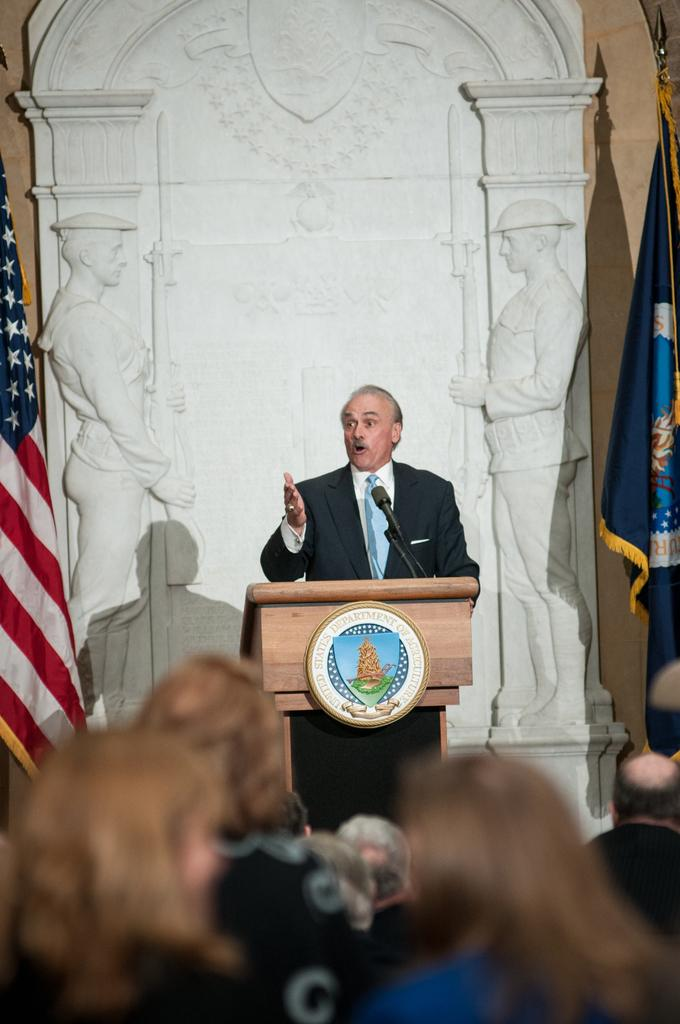What is the person standing behind in the image? The person is standing behind a podium. What can be found on the podium? There is a microphone and a logo on the podium. What is visible behind the person? There are sculptures and flags behind the person. Who is in front of the person? There are audiences in front of the person. What is the texture of the growth on the sculptures behind the person? There is no growth on the sculptures in the image, and therefore no texture can be described. 